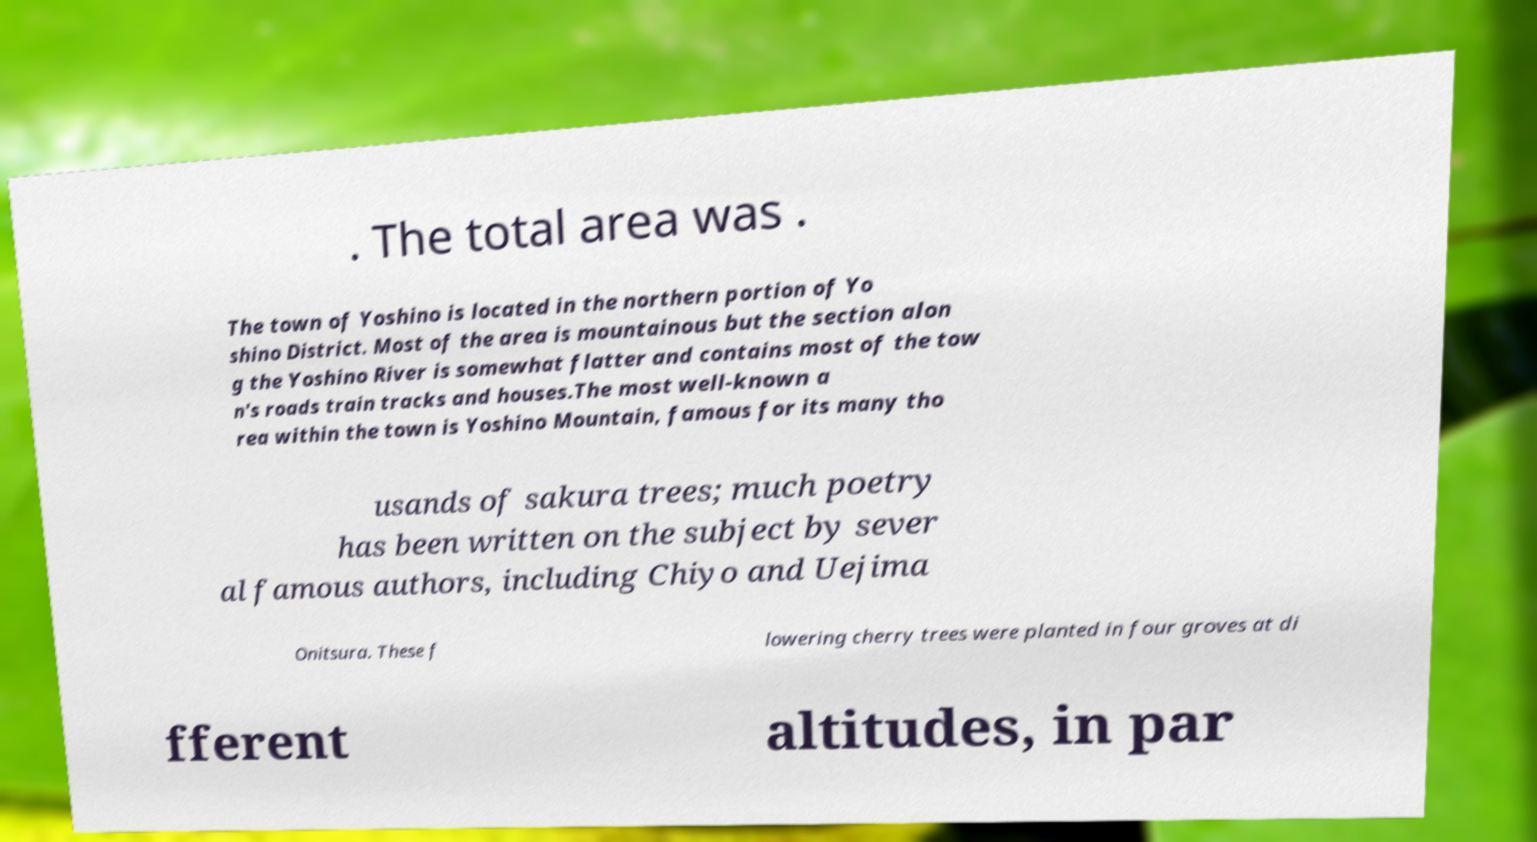There's text embedded in this image that I need extracted. Can you transcribe it verbatim? . The total area was . The town of Yoshino is located in the northern portion of Yo shino District. Most of the area is mountainous but the section alon g the Yoshino River is somewhat flatter and contains most of the tow n's roads train tracks and houses.The most well-known a rea within the town is Yoshino Mountain, famous for its many tho usands of sakura trees; much poetry has been written on the subject by sever al famous authors, including Chiyo and Uejima Onitsura. These f lowering cherry trees were planted in four groves at di fferent altitudes, in par 